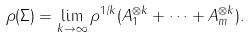<formula> <loc_0><loc_0><loc_500><loc_500>\rho ( \Sigma ) = \lim _ { k \rightarrow \infty } { \rho ^ { 1 / k } ( A _ { 1 } ^ { \otimes k } + \cdots + A _ { m } ^ { \otimes k } ) } .</formula> 